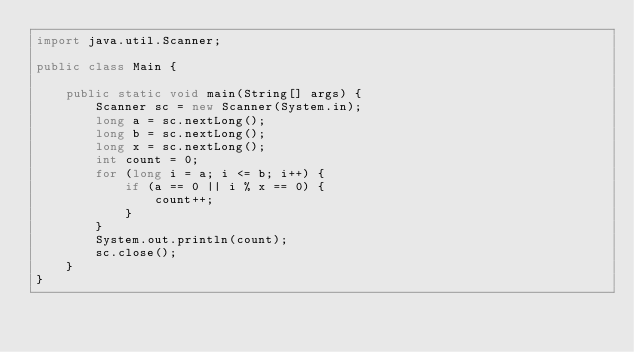Convert code to text. <code><loc_0><loc_0><loc_500><loc_500><_Java_>import java.util.Scanner;

public class Main {

	public static void main(String[] args) {
		Scanner sc = new Scanner(System.in);
		long a = sc.nextLong();
		long b = sc.nextLong();
		long x = sc.nextLong();
		int count = 0;
		for (long i = a; i <= b; i++) {
			if (a == 0 || i % x == 0) {
				count++;
			}
		}
		System.out.println(count);
		sc.close();
	}
}</code> 